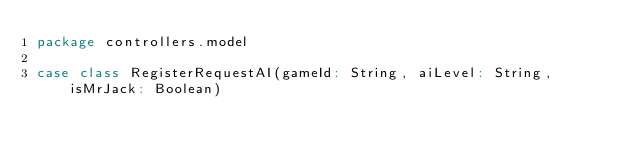<code> <loc_0><loc_0><loc_500><loc_500><_Scala_>package controllers.model

case class RegisterRequestAI(gameId: String, aiLevel: String, isMrJack: Boolean)
</code> 